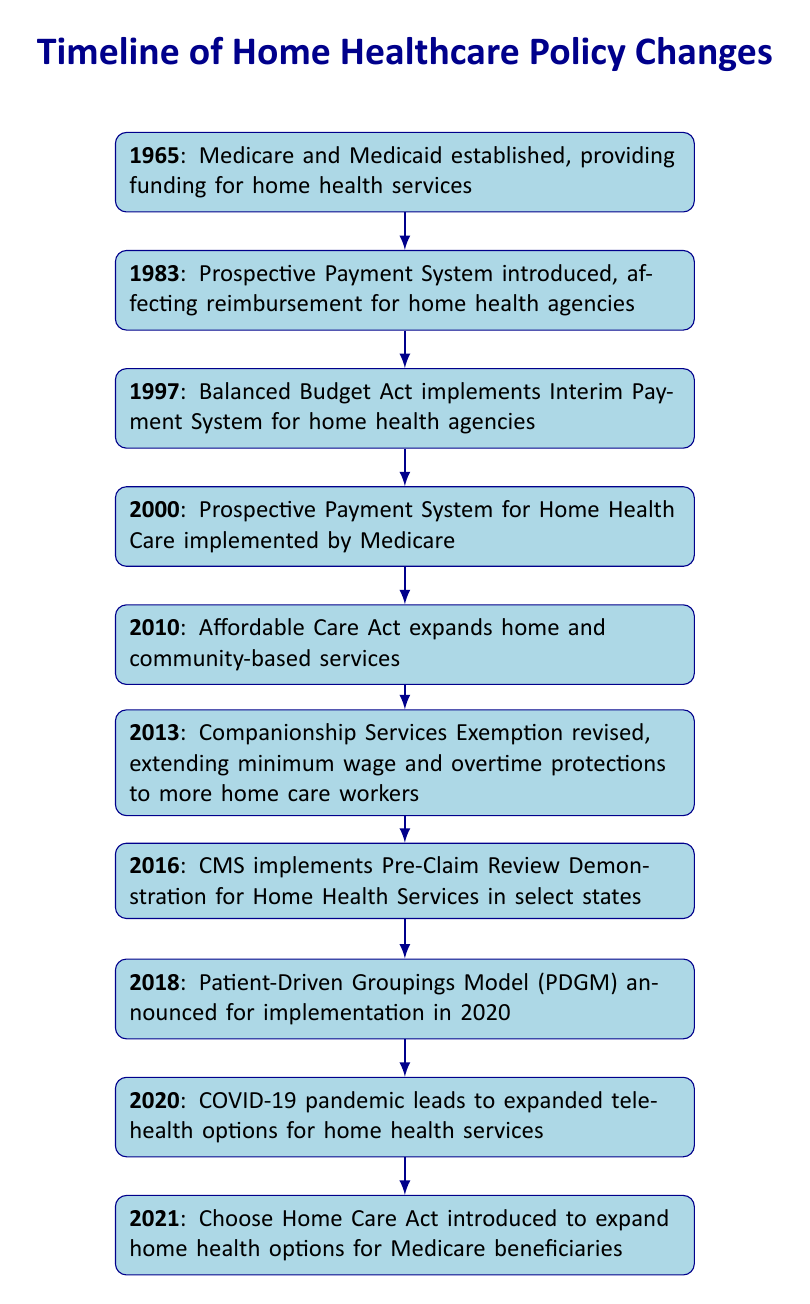What significant change occurred in healthcare policy in 1965? The table indicates that in 1965, Medicare and Medicaid were established, which provided funding for home health services.
Answer: Medicare and Medicaid established What year did the Patient-Driven Groupings Model (PDGM) get announced? According to the table, the Patient-Driven Groupings Model (PDGM) was announced in 2018, with implementation scheduled for 2020.
Answer: 2018 How many years passed between the introduction of the Prospective Payment System in 1983 and the implementation of the Prospective Payment System for Home Health Care in 2000? The Prospective Payment System was introduced in 1983 and implemented for Home Health Care in 2000. To calculate the difference: 2000 - 1983 = 17 years.
Answer: 17 Is it true that the Affordable Care Act expanded home and community-based services? The table confirms that in 2010, the Affordable Care Act indeed expanded home and community-based services.
Answer: Yes Which event in the timeline involved changes to protections for home healthcare workers? In 2013, the Companionship Services Exemption was revised, which extended minimum wage and overtime protections to more home care workers.
Answer: Revision of Companionship Services Exemption What is the difference in years between the introduction of the Balanced Budget Act and the introduction of the Choose Home Care Act? The Balanced Budget Act was introduced in 1997 and the Choose Home Care Act was introduced in 2021. The difference in years is calculated as 2021 - 1997 = 24 years.
Answer: 24 How many events in the timeline occurred after the year 2000? The timeline lists six events after the year 2000: in 2010, 2013, 2016, 2018, 2020, and 2021. Therefore, the count is confirmed as six events.
Answer: 6 In which year did the COVID-19 pandemic lead to expanded telehealth options for home health services? The table states that the COVID-19 pandemic led to expanded telehealth options for home health services in the year 2020.
Answer: 2020 What major restructuring of payment for home health agencies took place in 1997? The table specifies that the Balanced Budget Act was enacted in 1997, which implemented an Interim Payment System for home health agencies, representing a significant change.
Answer: Interim Payment System implemented 